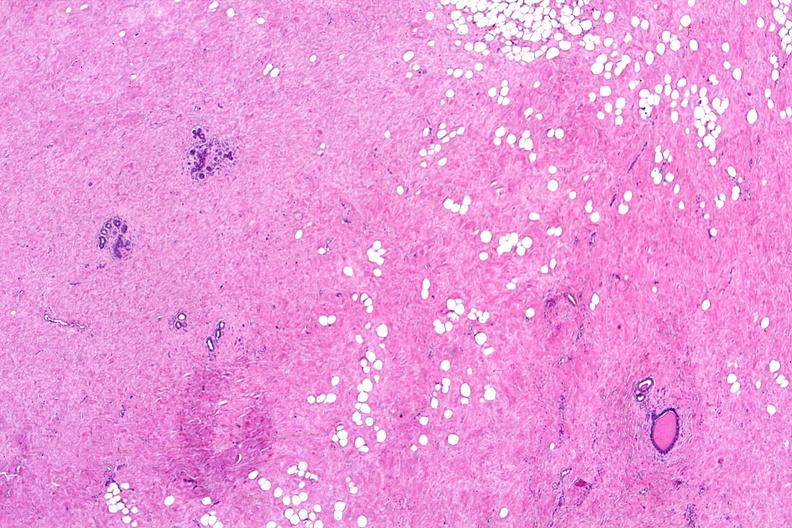does this image show normal breast?
Answer the question using a single word or phrase. Yes 